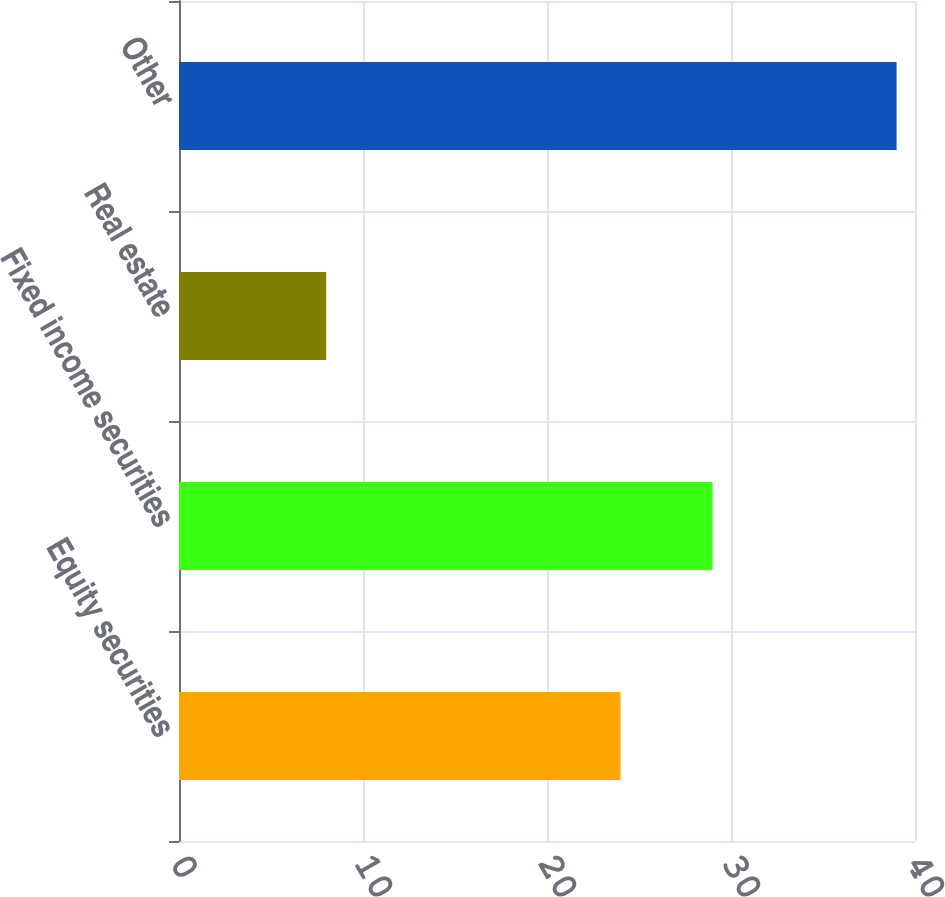<chart> <loc_0><loc_0><loc_500><loc_500><bar_chart><fcel>Equity securities<fcel>Fixed income securities<fcel>Real estate<fcel>Other<nl><fcel>24<fcel>29<fcel>8<fcel>39<nl></chart> 